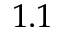<formula> <loc_0><loc_0><loc_500><loc_500>1 . 1</formula> 